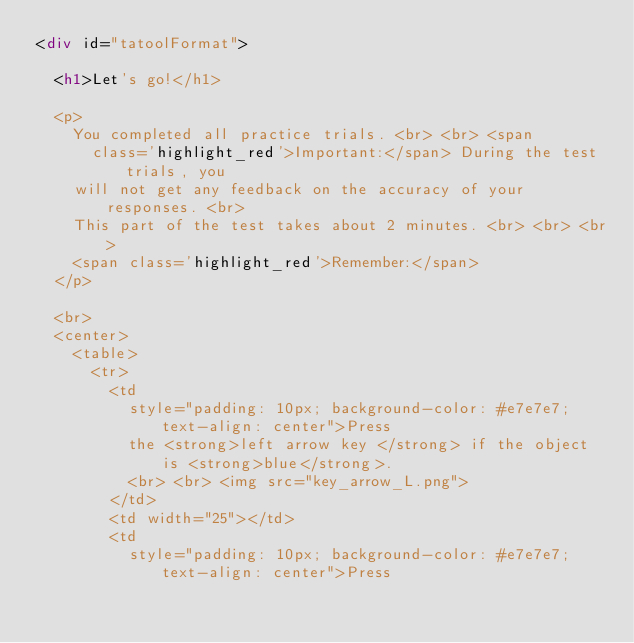Convert code to text. <code><loc_0><loc_0><loc_500><loc_500><_HTML_><div id="tatoolFormat">

	<h1>Let's go!</h1>

	<p>
		You completed all practice trials. <br> <br> <span
			class='highlight_red'>Important:</span> During the test trials, you
		will not get any feedback on the accuracy of your responses. <br>
		This part of the test takes about 2 minutes. <br> <br> <br>
		<span class='highlight_red'>Remember:</span>
	</p>

	<br>
	<center>
		<table>
			<tr>
				<td
					style="padding: 10px; background-color: #e7e7e7; text-align: center">Press
					the <strong>left arrow key </strong> if the object is <strong>blue</strong>.
					<br> <br> <img src="key_arrow_L.png">
				</td>
				<td width="25"></td>
				<td
					style="padding: 10px; background-color: #e7e7e7; text-align: center">Press</code> 